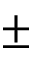Convert formula to latex. <formula><loc_0><loc_0><loc_500><loc_500>\pm</formula> 